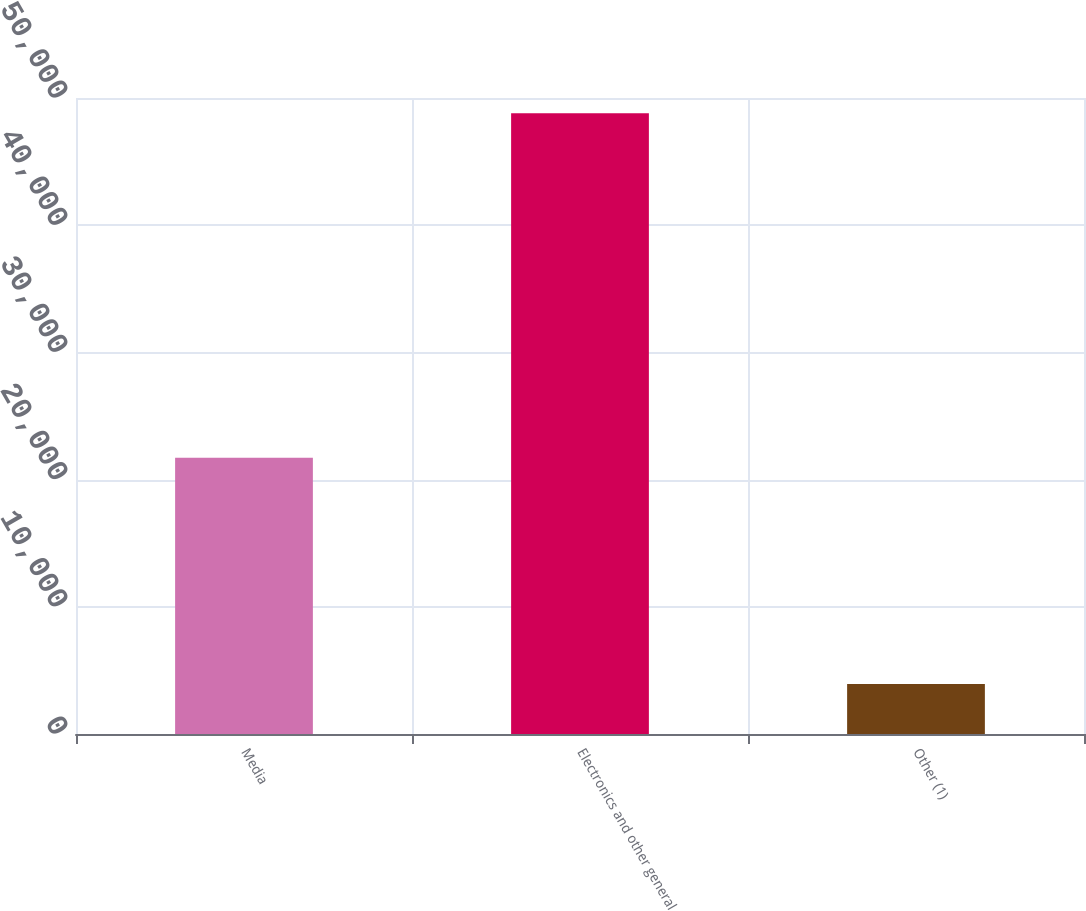Convert chart to OTSL. <chart><loc_0><loc_0><loc_500><loc_500><bar_chart><fcel>Media<fcel>Electronics and other general<fcel>Other (1)<nl><fcel>21716<fcel>48802<fcel>3934<nl></chart> 